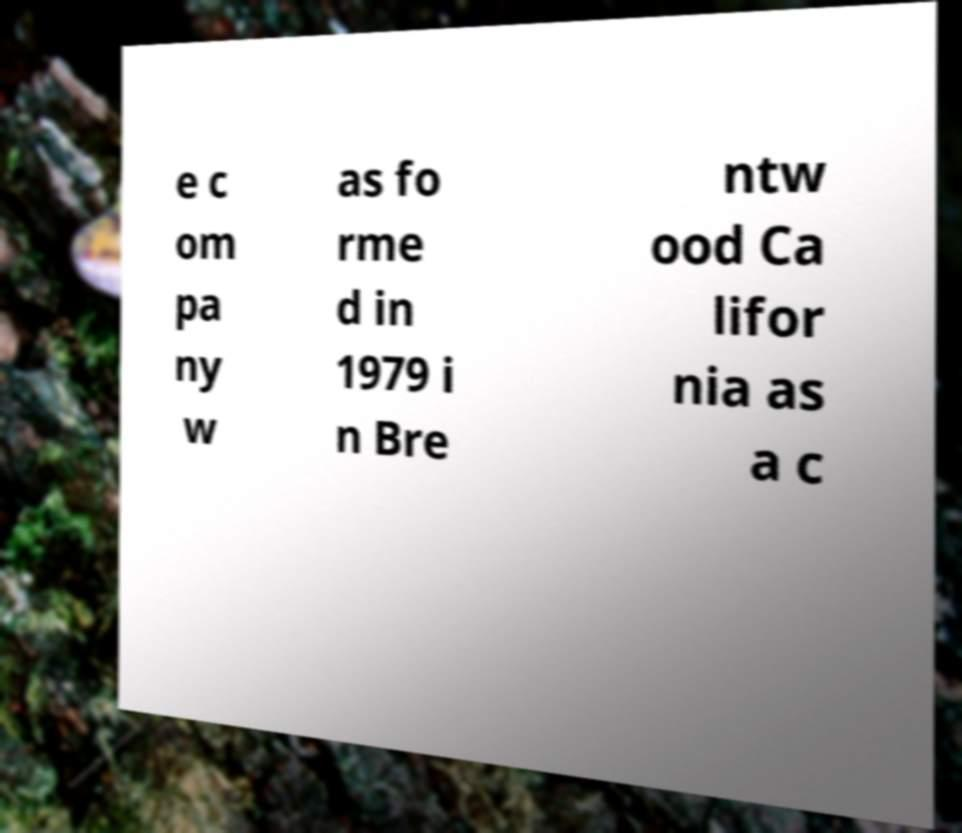I need the written content from this picture converted into text. Can you do that? e c om pa ny w as fo rme d in 1979 i n Bre ntw ood Ca lifor nia as a c 